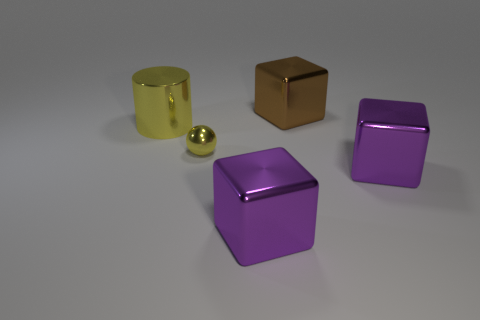How many metal things are small spheres or large red objects?
Provide a short and direct response. 1. Do the object on the left side of the small yellow sphere and the large block behind the tiny shiny ball have the same material?
Make the answer very short. Yes. Are any matte blocks visible?
Give a very brief answer. No. Is the shape of the yellow object that is on the right side of the cylinder the same as the large object right of the brown metal cube?
Your answer should be very brief. No. Are there any big yellow objects made of the same material as the brown block?
Offer a very short reply. Yes. Does the cube that is behind the yellow cylinder have the same material as the big yellow thing?
Provide a short and direct response. Yes. Is the number of large blocks in front of the small yellow object greater than the number of tiny spheres that are behind the big brown metallic thing?
Make the answer very short. Yes. There is a shiny cylinder that is the same size as the brown shiny object; what color is it?
Provide a succinct answer. Yellow. Are there any big shiny spheres of the same color as the big shiny cylinder?
Offer a terse response. No. There is a shiny cube behind the yellow shiny cylinder; does it have the same color as the thing on the left side of the yellow shiny ball?
Provide a short and direct response. No. 